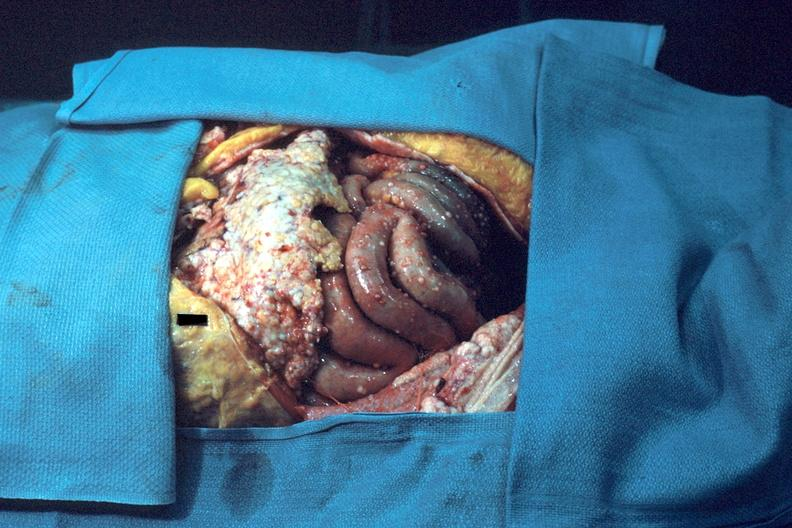does this image show opened abdominal cavity show typical carcinomatosis?
Answer the question using a single word or phrase. Yes 